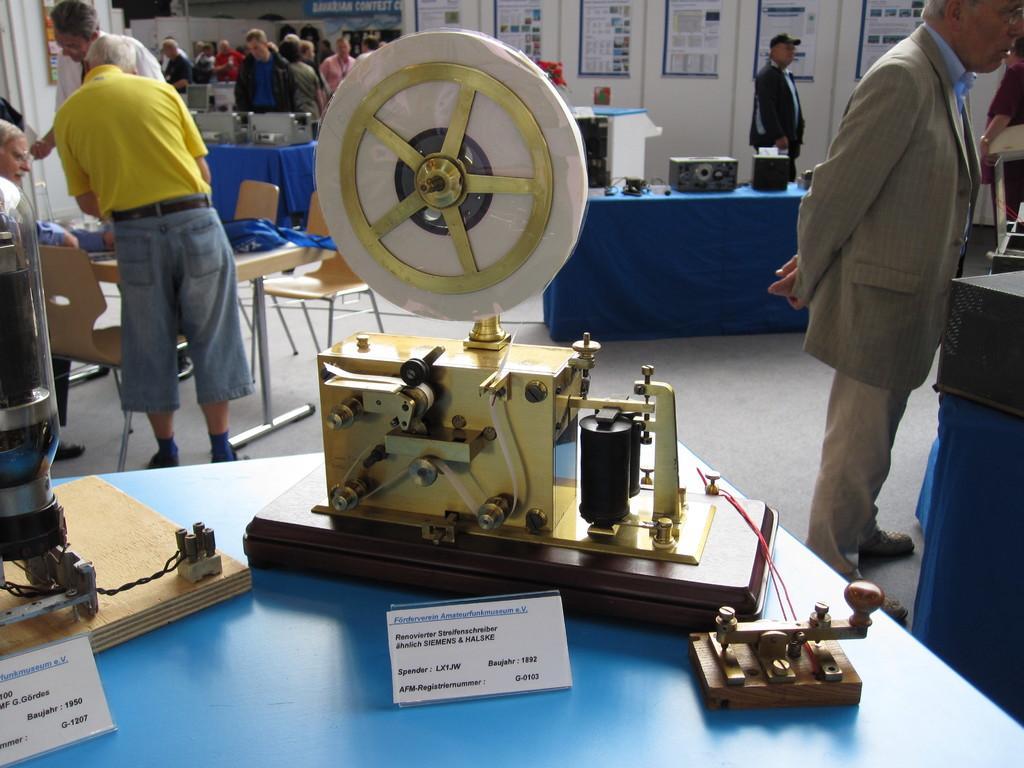Can you describe this image briefly? In this image I can see a blue colored table and on it I can see few equipments and few boards which are white in color. I can see few persons standing and few persons sitting. In the background I can see number of persons standing, few tables which are blue in color, on the tables I can see few equipment's, the white colored wall and few poster attached to the wall. 